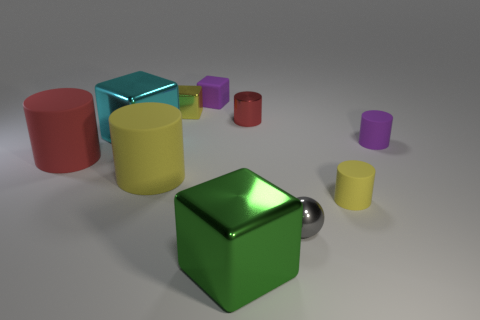Do the purple object that is to the right of the metal sphere and the green metal thing that is in front of the red rubber object have the same shape?
Make the answer very short. No. What is the yellow block made of?
Offer a very short reply. Metal. There is a tiny cube on the left side of the purple block; what is its material?
Your answer should be very brief. Metal. Are there any other things that are the same color as the tiny rubber cube?
Provide a succinct answer. Yes. What size is the red thing that is the same material as the green thing?
Provide a succinct answer. Small. What number of tiny things are gray things or purple metal spheres?
Offer a very short reply. 1. There is a red object on the left side of the rubber object behind the red thing right of the small metallic cube; how big is it?
Make the answer very short. Large. What number of yellow shiny cubes are the same size as the red rubber thing?
Ensure brevity in your answer.  0. What number of objects are big brown metal balls or yellow matte things that are on the right side of the gray metal thing?
Keep it short and to the point. 1. There is a gray shiny object; what shape is it?
Make the answer very short. Sphere. 